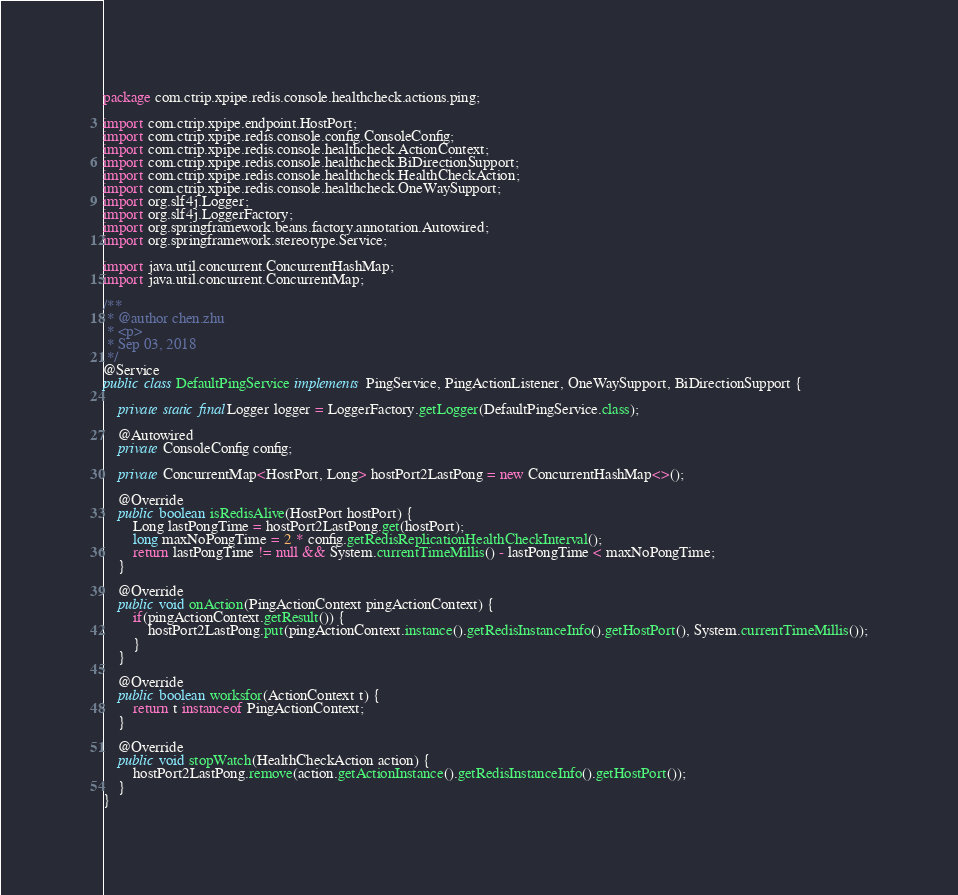Convert code to text. <code><loc_0><loc_0><loc_500><loc_500><_Java_>package com.ctrip.xpipe.redis.console.healthcheck.actions.ping;

import com.ctrip.xpipe.endpoint.HostPort;
import com.ctrip.xpipe.redis.console.config.ConsoleConfig;
import com.ctrip.xpipe.redis.console.healthcheck.ActionContext;
import com.ctrip.xpipe.redis.console.healthcheck.BiDirectionSupport;
import com.ctrip.xpipe.redis.console.healthcheck.HealthCheckAction;
import com.ctrip.xpipe.redis.console.healthcheck.OneWaySupport;
import org.slf4j.Logger;
import org.slf4j.LoggerFactory;
import org.springframework.beans.factory.annotation.Autowired;
import org.springframework.stereotype.Service;

import java.util.concurrent.ConcurrentHashMap;
import java.util.concurrent.ConcurrentMap;

/**
 * @author chen.zhu
 * <p>
 * Sep 03, 2018
 */
@Service
public class DefaultPingService implements PingService, PingActionListener, OneWaySupport, BiDirectionSupport {

    private static final Logger logger = LoggerFactory.getLogger(DefaultPingService.class);

    @Autowired
    private ConsoleConfig config;

    private ConcurrentMap<HostPort, Long> hostPort2LastPong = new ConcurrentHashMap<>();

    @Override
    public boolean isRedisAlive(HostPort hostPort) {
        Long lastPongTime = hostPort2LastPong.get(hostPort);
        long maxNoPongTime = 2 * config.getRedisReplicationHealthCheckInterval();
        return lastPongTime != null && System.currentTimeMillis() - lastPongTime < maxNoPongTime;
    }

    @Override
    public void onAction(PingActionContext pingActionContext) {
        if(pingActionContext.getResult()) {
            hostPort2LastPong.put(pingActionContext.instance().getRedisInstanceInfo().getHostPort(), System.currentTimeMillis());
        }
    }

    @Override
    public boolean worksfor(ActionContext t) {
        return t instanceof PingActionContext;
    }

    @Override
    public void stopWatch(HealthCheckAction action) {
        hostPort2LastPong.remove(action.getActionInstance().getRedisInstanceInfo().getHostPort());
    }
}
</code> 